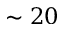Convert formula to latex. <formula><loc_0><loc_0><loc_500><loc_500>\sim 2 0</formula> 